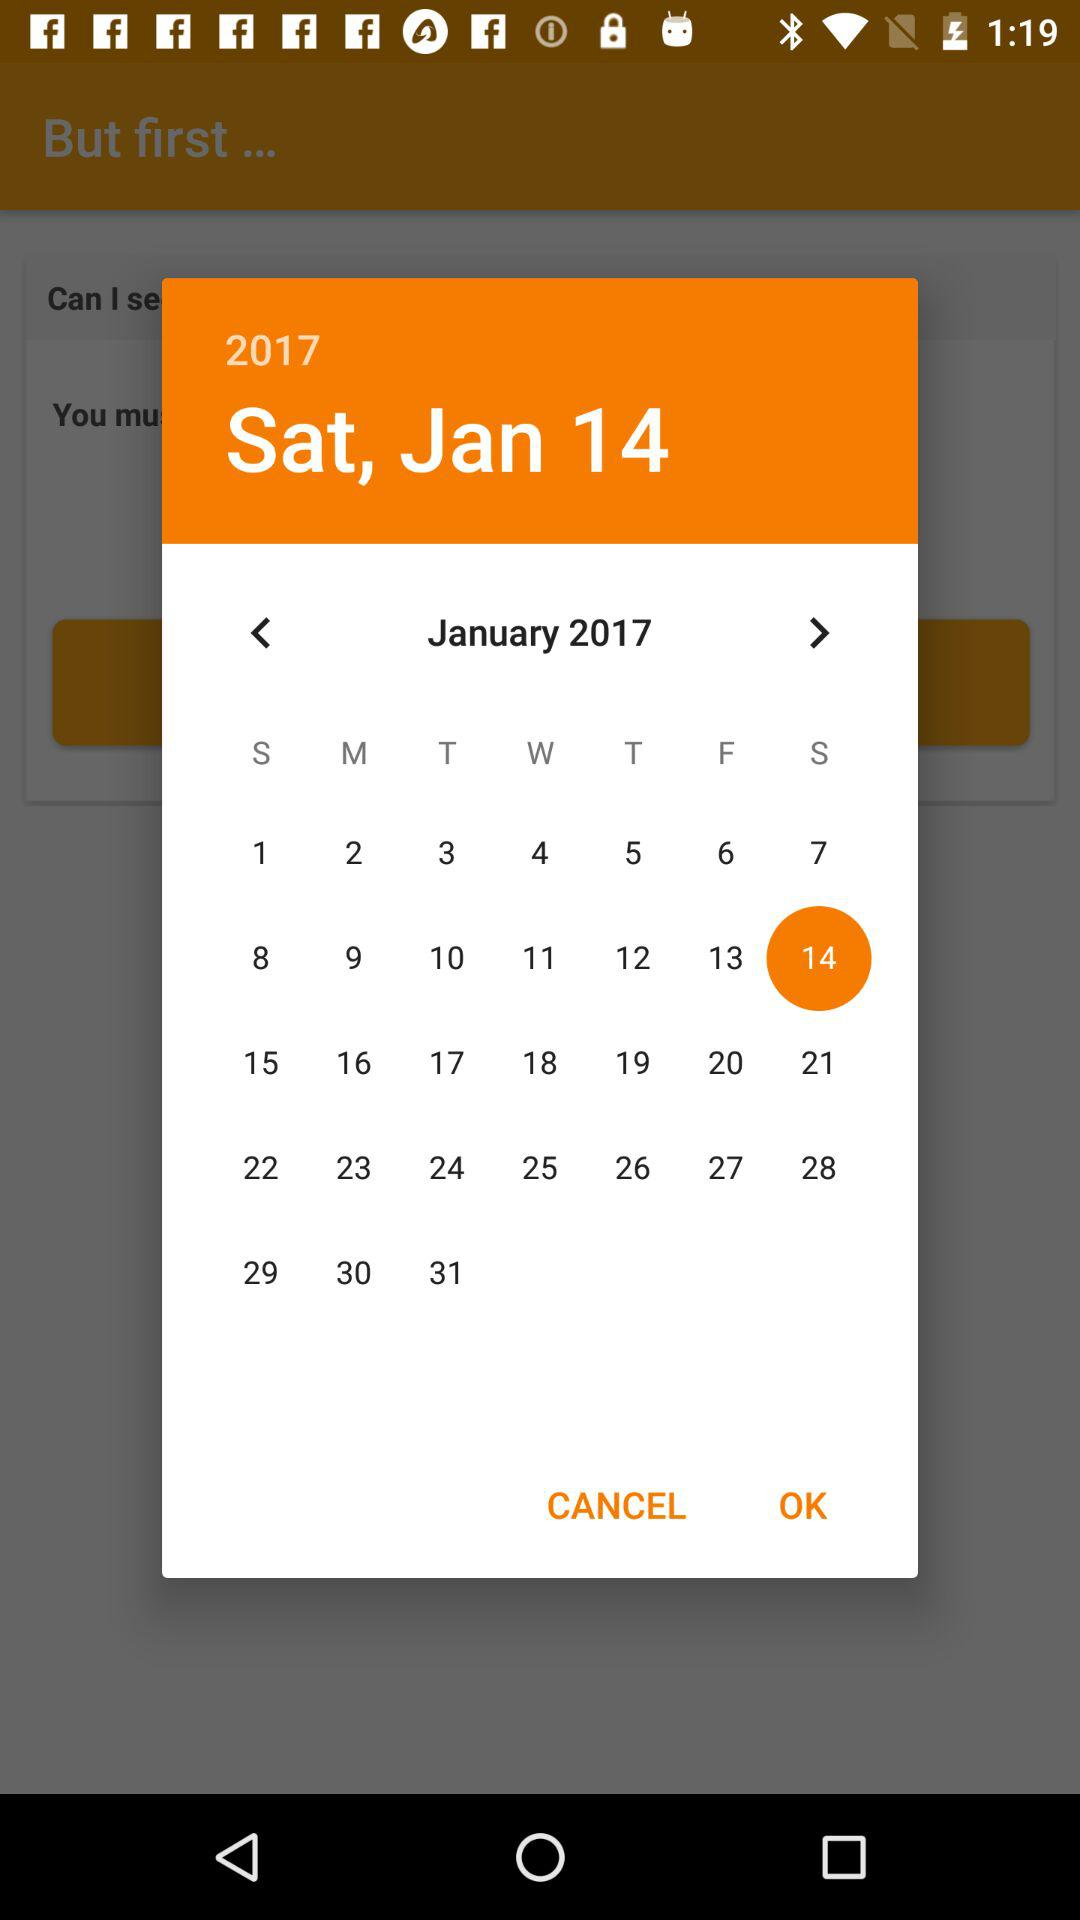Which date is selected on the calendar? The date selected on the calendar is Saturday, January 14, 2017. 